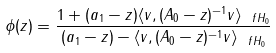Convert formula to latex. <formula><loc_0><loc_0><loc_500><loc_500>\phi ( z ) = \frac { 1 + ( a _ { 1 } - z ) \langle v , ( A _ { 0 } - z ) ^ { - 1 } v \rangle _ { \ f H _ { 0 } } } { ( a _ { 1 } - z ) - \langle v , ( A _ { 0 } - z ) ^ { - 1 } v \rangle _ { \ f H _ { 0 } } }</formula> 